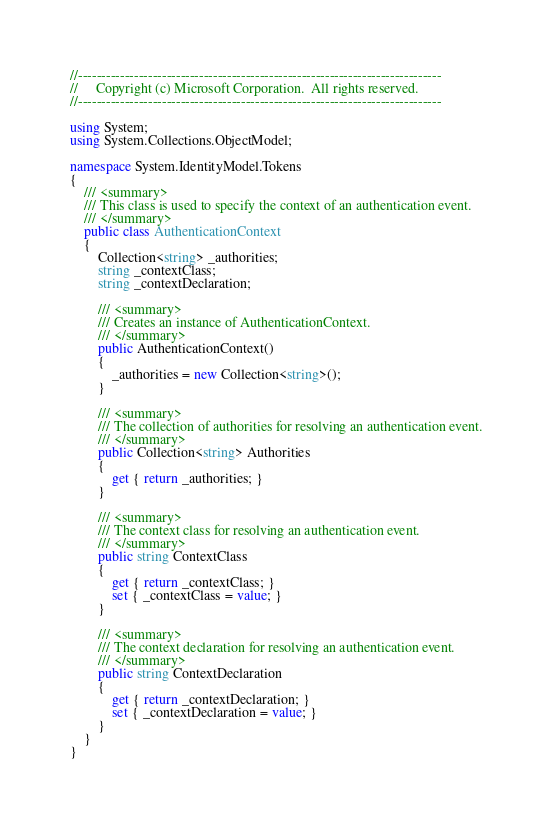<code> <loc_0><loc_0><loc_500><loc_500><_C#_>//------------------------------------------------------------------------------
//     Copyright (c) Microsoft Corporation.  All rights reserved.
//------------------------------------------------------------------------------

using System;
using System.Collections.ObjectModel;

namespace System.IdentityModel.Tokens
{
    /// <summary>
    /// This class is used to specify the context of an authentication event.
    /// </summary>
    public class AuthenticationContext
    {
        Collection<string> _authorities; 
        string _contextClass;
        string _contextDeclaration;
        
        /// <summary>
        /// Creates an instance of AuthenticationContext.
        /// </summary>
        public AuthenticationContext()
        {
            _authorities = new Collection<string>();
        }

        /// <summary>
        /// The collection of authorities for resolving an authentication event.
        /// </summary>
        public Collection<string> Authorities
        {
            get { return _authorities; }
        }

        /// <summary>
        /// The context class for resolving an authentication event.
        /// </summary>
        public string ContextClass
        {
            get { return _contextClass; }
            set { _contextClass = value; }
        }

        /// <summary>
        /// The context declaration for resolving an authentication event.
        /// </summary>
        public string ContextDeclaration
        {
            get { return _contextDeclaration; }
            set { _contextDeclaration = value; }
        }
    }
}
</code> 